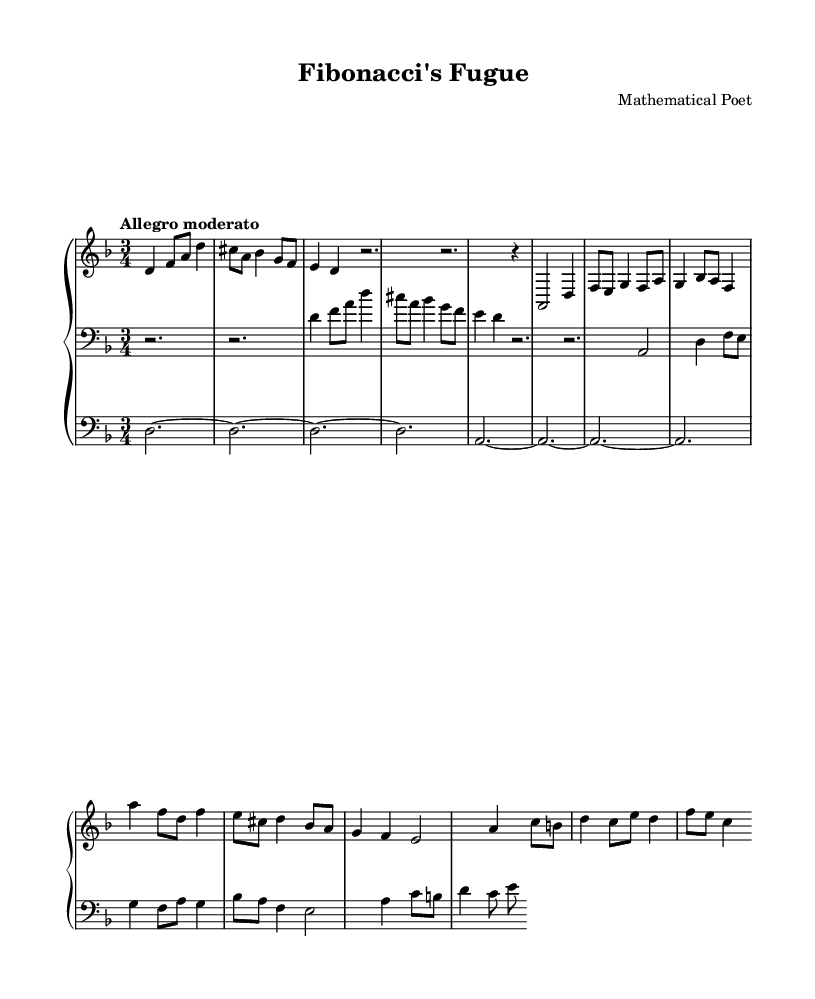What is the key signature of this music? The key signature is indicated by the sharps or flats at the beginning of the staff. In this piece, there are two sharps (F# and C#), which signifies D major or its relative minor, B minor. However, the presence of B flats later indicates that the piece is centered around D minor.
Answer: D minor What is the time signature of the piece? The time signature is located at the beginning of the score, represented by two numbers stacked vertically. Here, it shows a 3 over 4, indicating that each measure contains three beats, with a quarter note getting one beat.
Answer: 3/4 What is the tempo marking for the piece? The tempo marking is typically found at the start of the music under the title, indicating how fast the piece should be played. In this case, it states "Allegro moderato," which suggests a moderately fast tempo.
Answer: Allegro moderato How many measures are in the upper staff? To find out the number of measures, count the groups of beats that fit within the structure of the music. Each group separated by bar lines counts as one measure. The upper staff in this piece has a total of 8 measures.
Answer: 8 What kind of fugue structure is employed in this piece? The piece displays characteristics of a Baroque fugue, where the main theme (subject) is introduced and subsequently developed with a counter-subject, followed by further entrances and developments that interlock melodically and harmonically, showcasing mathematical patterns such as inversions.
Answer: Expository and developmental What is the name of the main musical theme in this fugue? The main musical theme can usually be identified as the "subject" written prominently at the beginning. Here, it is referred to as the "subject" in the score and introduced clearly in the upper staff.
Answer: Fibonacci's Fugue subject How does the counter-subject relate to the main subject? The counter-subject serves as a complementary melody to the main subject, often entered at the same point in the harmony, with voices weaving around each other. In this piece, after the subject is introduced, the counter-subject is layered to create complexity, showcasing mathematical weaving of lines.
Answer: Complementary and interlocking 